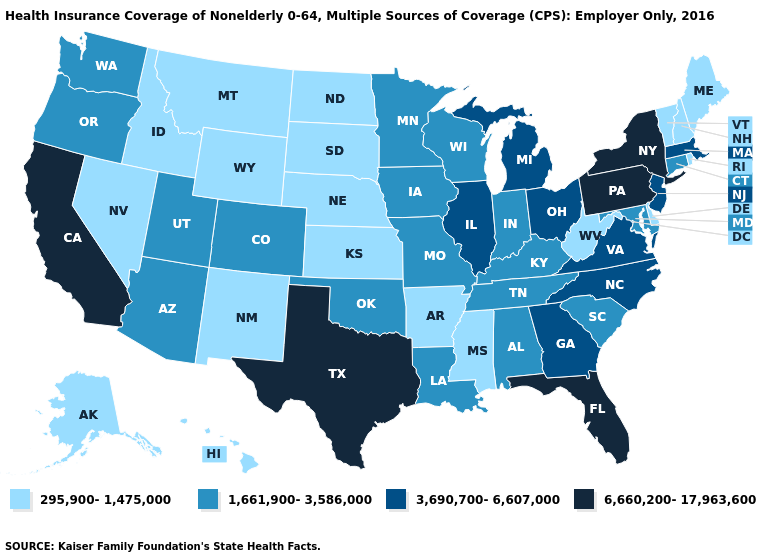What is the value of New Jersey?
Write a very short answer. 3,690,700-6,607,000. What is the value of South Dakota?
Answer briefly. 295,900-1,475,000. Among the states that border Michigan , does Wisconsin have the highest value?
Keep it brief. No. Does Maine have the lowest value in the USA?
Be succinct. Yes. Among the states that border Pennsylvania , does Ohio have the lowest value?
Quick response, please. No. Name the states that have a value in the range 6,660,200-17,963,600?
Answer briefly. California, Florida, New York, Pennsylvania, Texas. Among the states that border Mississippi , does Alabama have the highest value?
Concise answer only. Yes. Is the legend a continuous bar?
Write a very short answer. No. How many symbols are there in the legend?
Keep it brief. 4. What is the value of Montana?
Be succinct. 295,900-1,475,000. Which states have the lowest value in the South?
Keep it brief. Arkansas, Delaware, Mississippi, West Virginia. Does Indiana have the same value as Oregon?
Concise answer only. Yes. Among the states that border West Virginia , which have the lowest value?
Be succinct. Kentucky, Maryland. Which states have the lowest value in the Northeast?
Concise answer only. Maine, New Hampshire, Rhode Island, Vermont. What is the value of New Mexico?
Quick response, please. 295,900-1,475,000. 